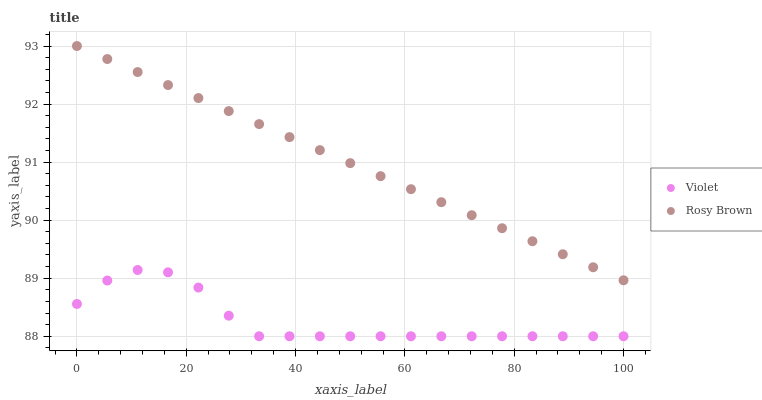Does Violet have the minimum area under the curve?
Answer yes or no. Yes. Does Rosy Brown have the maximum area under the curve?
Answer yes or no. Yes. Does Violet have the maximum area under the curve?
Answer yes or no. No. Is Rosy Brown the smoothest?
Answer yes or no. Yes. Is Violet the roughest?
Answer yes or no. Yes. Is Violet the smoothest?
Answer yes or no. No. Does Violet have the lowest value?
Answer yes or no. Yes. Does Rosy Brown have the highest value?
Answer yes or no. Yes. Does Violet have the highest value?
Answer yes or no. No. Is Violet less than Rosy Brown?
Answer yes or no. Yes. Is Rosy Brown greater than Violet?
Answer yes or no. Yes. Does Violet intersect Rosy Brown?
Answer yes or no. No. 